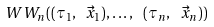<formula> <loc_0><loc_0><loc_500><loc_500>\ W W _ { n } ( ( \tau _ { 1 } , \ \vec { x } _ { 1 } ) , \dots , \ ( \tau _ { n } , \ \vec { x } _ { n } ) )</formula> 